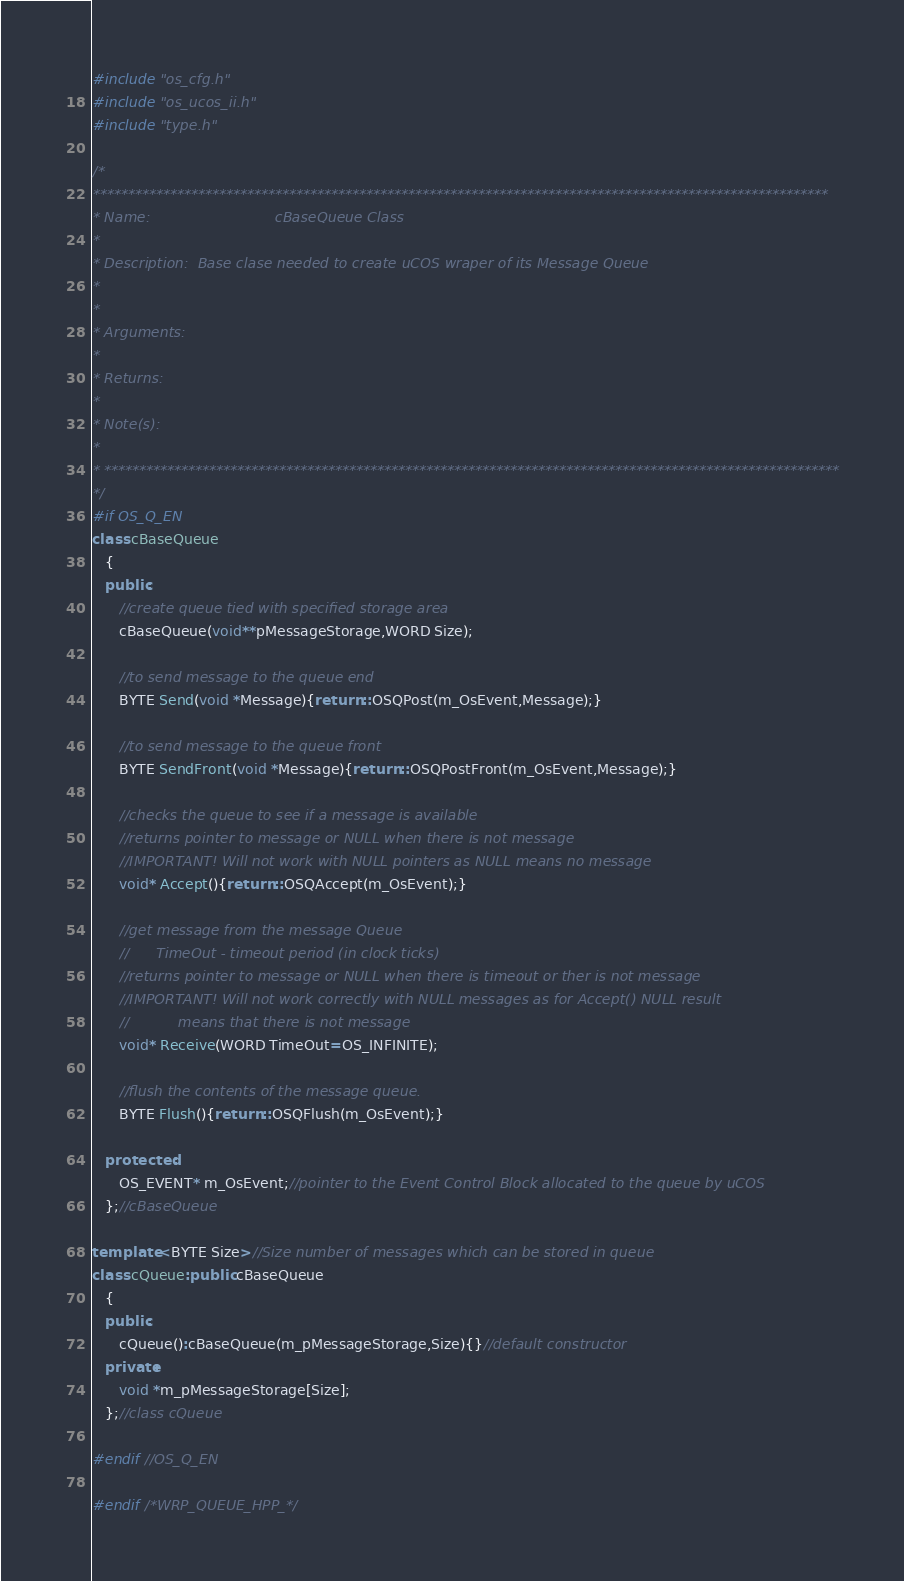<code> <loc_0><loc_0><loc_500><loc_500><_C++_>#include "os_cfg.h"
#include "os_ucos_ii.h"
#include "type.h"

/*
*********************************************************************************************************
* Name:                            cBaseQueue Class 
* 
* Description: 	Base clase needed to create uCOS wraper of its Message Queue
*       
*
* Arguments:   
*
* Returns:  
*
* Note(s):     
*
* *********************************************************************************************************
*/ 
#if OS_Q_EN
class cBaseQueue
   {
   public:
      //create queue tied with specified storage area
      cBaseQueue(void**pMessageStorage,WORD Size);  

      //to send message to the queue end
      BYTE Send(void *Message){return ::OSQPost(m_OsEvent,Message);}

      //to send message to the queue front
      BYTE SendFront(void *Message){return ::OSQPostFront(m_OsEvent,Message);}

      //checks the queue to see if a message is available
      //returns pointer to message or NULL when there is not message
      //IMPORTANT! Will not work with NULL pointers as NULL means no message
      void* Accept(){return ::OSQAccept(m_OsEvent);}

      //get message from the message Queue
      //   	TimeOut - timeout period (in clock ticks)
      //returns pointer to message or NULL when there is timeout or ther is not message
      //IMPORTANT! Will not work correctly with NULL messages as for Accept() NULL result
      //           means that there is not message
      void* Receive(WORD TimeOut=OS_INFINITE);

      //flush the contents of the message queue.
      BYTE Flush(){return ::OSQFlush(m_OsEvent);}
      
   protected:
      OS_EVENT* m_OsEvent;//pointer to the Event Control Block allocated to the queue by uCOS
   };//cBaseQueue

template <BYTE Size>//Size number of messages which can be stored in queue
class cQueue:public cBaseQueue
   {
   public:
      cQueue():cBaseQueue(m_pMessageStorage,Size){}//default constructor
   private:
      void *m_pMessageStorage[Size];
   };//class cQueue

#endif //OS_Q_EN

#endif /*WRP_QUEUE_HPP_*/
</code> 